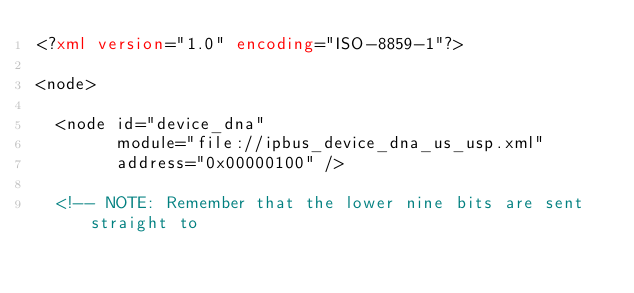Convert code to text. <code><loc_0><loc_0><loc_500><loc_500><_XML_><?xml version="1.0" encoding="ISO-8859-1"?>

<node>

  <node id="device_dna"
        module="file://ipbus_device_dna_us_usp.xml"
        address="0x00000100" />

  <!-- NOTE: Remember that the lower nine bits are sent straight to</code> 